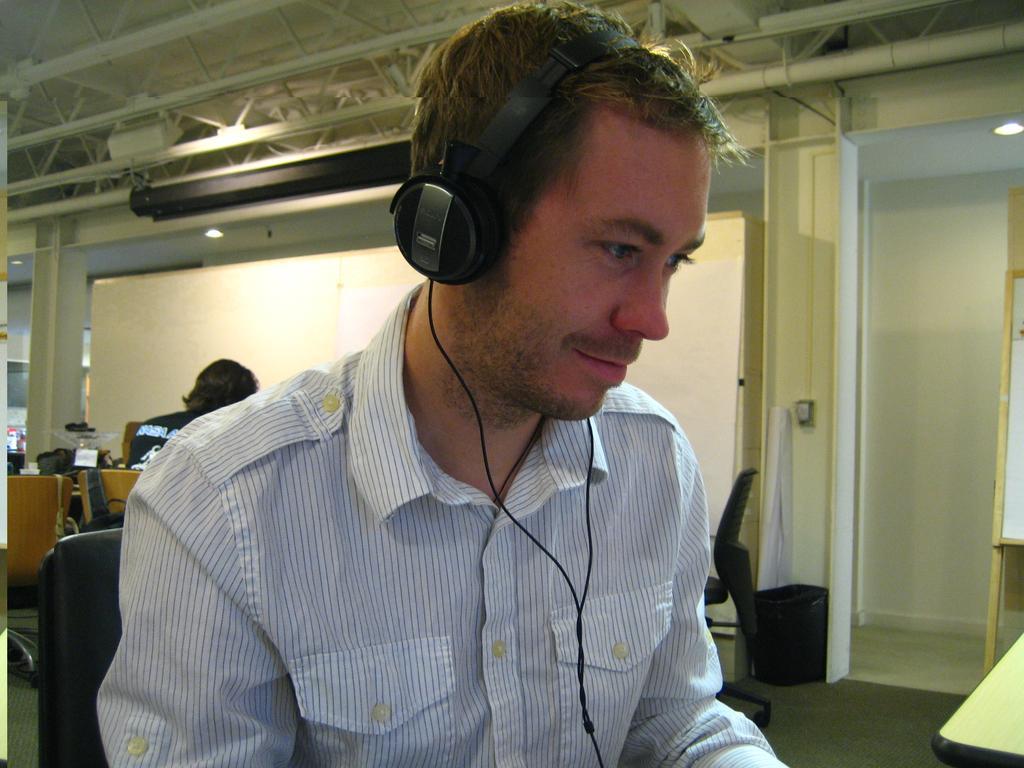Could you give a brief overview of what you see in this image? In this image there is a person sat on the chair and he is wearing a headset on his head. On the right side of the image there is a table, behind the person there is another person sat on the chair and there are a few chairs and tables with some stuff on it. At the top of the image there is a ceiling. In the background there is a wall. 